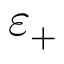<formula> <loc_0><loc_0><loc_500><loc_500>\varepsilon _ { + }</formula> 